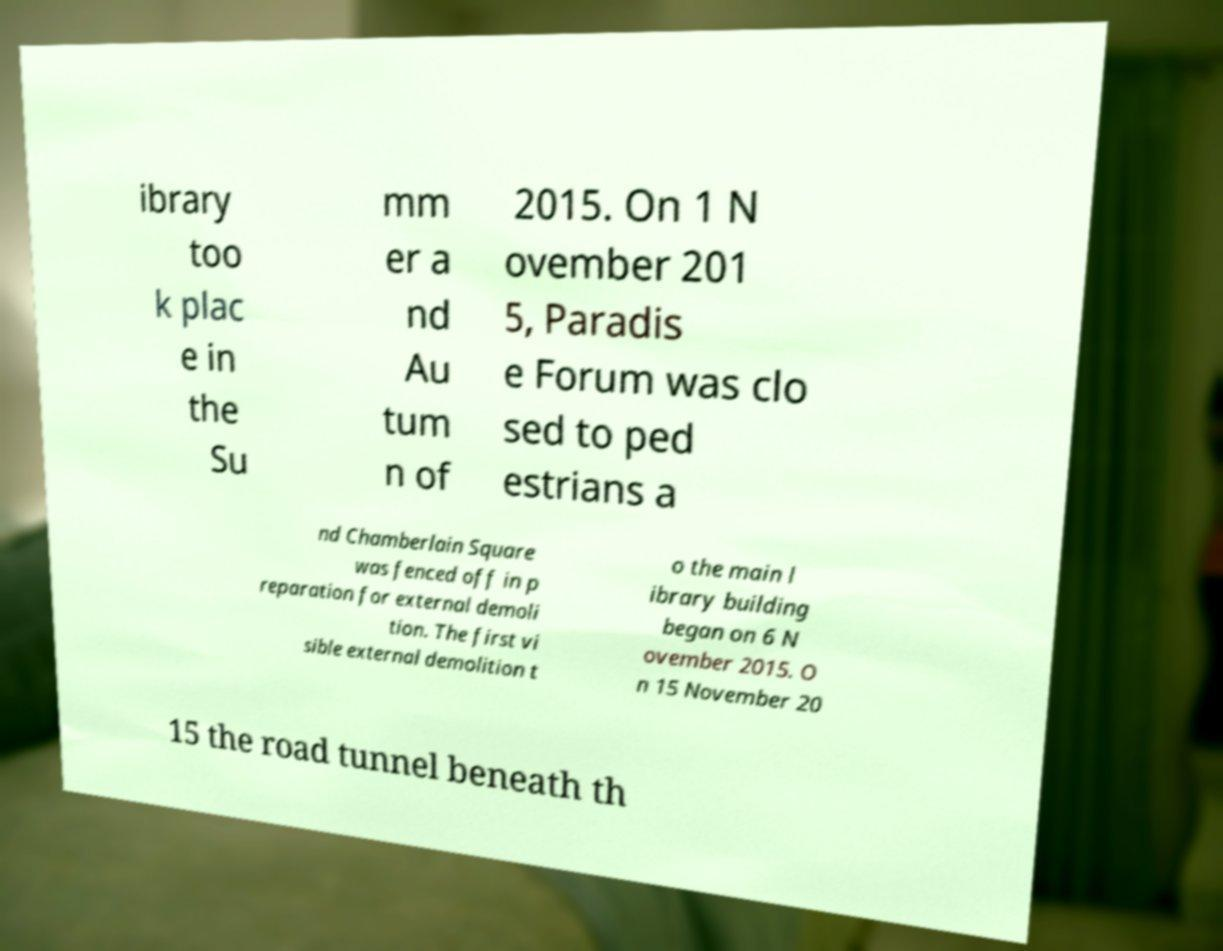Please identify and transcribe the text found in this image. ibrary too k plac e in the Su mm er a nd Au tum n of 2015. On 1 N ovember 201 5, Paradis e Forum was clo sed to ped estrians a nd Chamberlain Square was fenced off in p reparation for external demoli tion. The first vi sible external demolition t o the main l ibrary building began on 6 N ovember 2015. O n 15 November 20 15 the road tunnel beneath th 